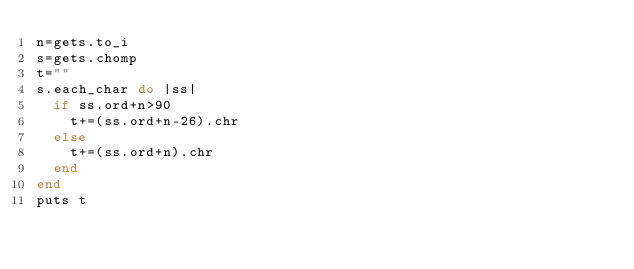<code> <loc_0><loc_0><loc_500><loc_500><_Ruby_>n=gets.to_i
s=gets.chomp
t=""
s.each_char do |ss|
  if ss.ord+n>90
    t+=(ss.ord+n-26).chr
  else
    t+=(ss.ord+n).chr
  end
end
puts t
</code> 